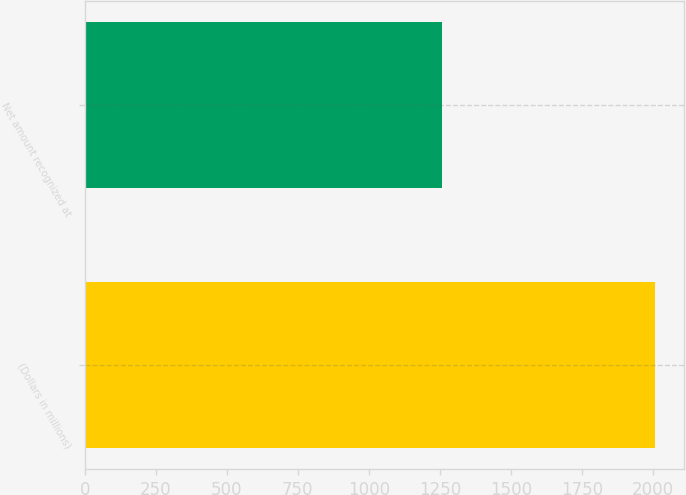<chart> <loc_0><loc_0><loc_500><loc_500><bar_chart><fcel>(Dollars in millions)<fcel>Net amount recognized at<nl><fcel>2008<fcel>1256<nl></chart> 